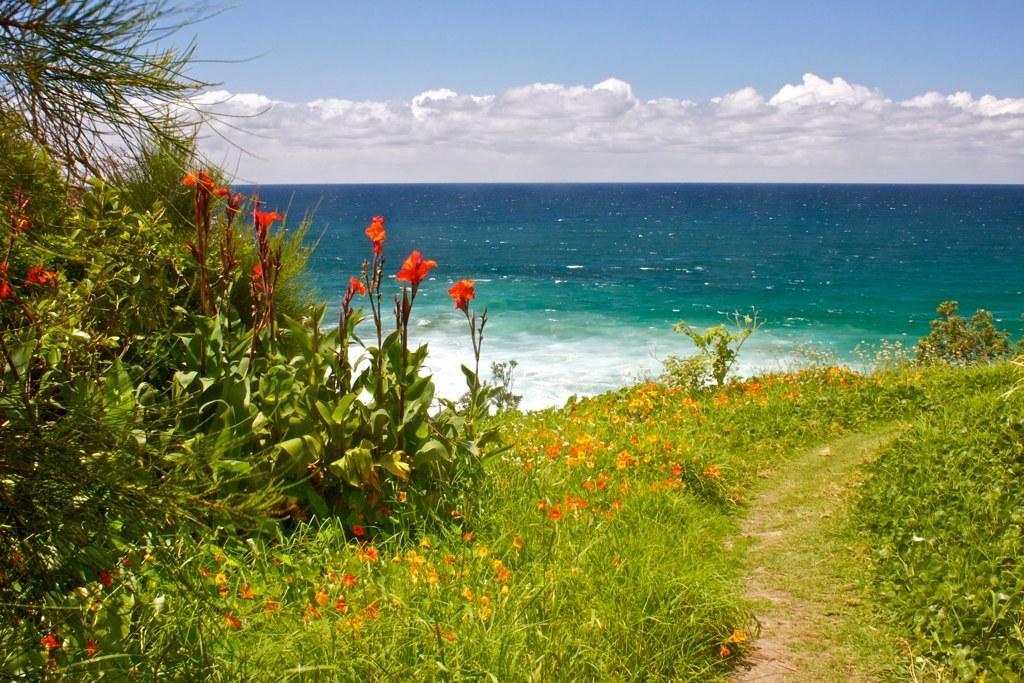What type of plants are visible in the image? There are plants with flowers in the image. What is the primary element that is visible in the image? Water is visible in the image. What can be seen in the background of the image? There is a sky visible in the background of the image. What type of letter can be seen floating in the water in the image? There is no letter present in the image; it only features plants with flowers and water. 